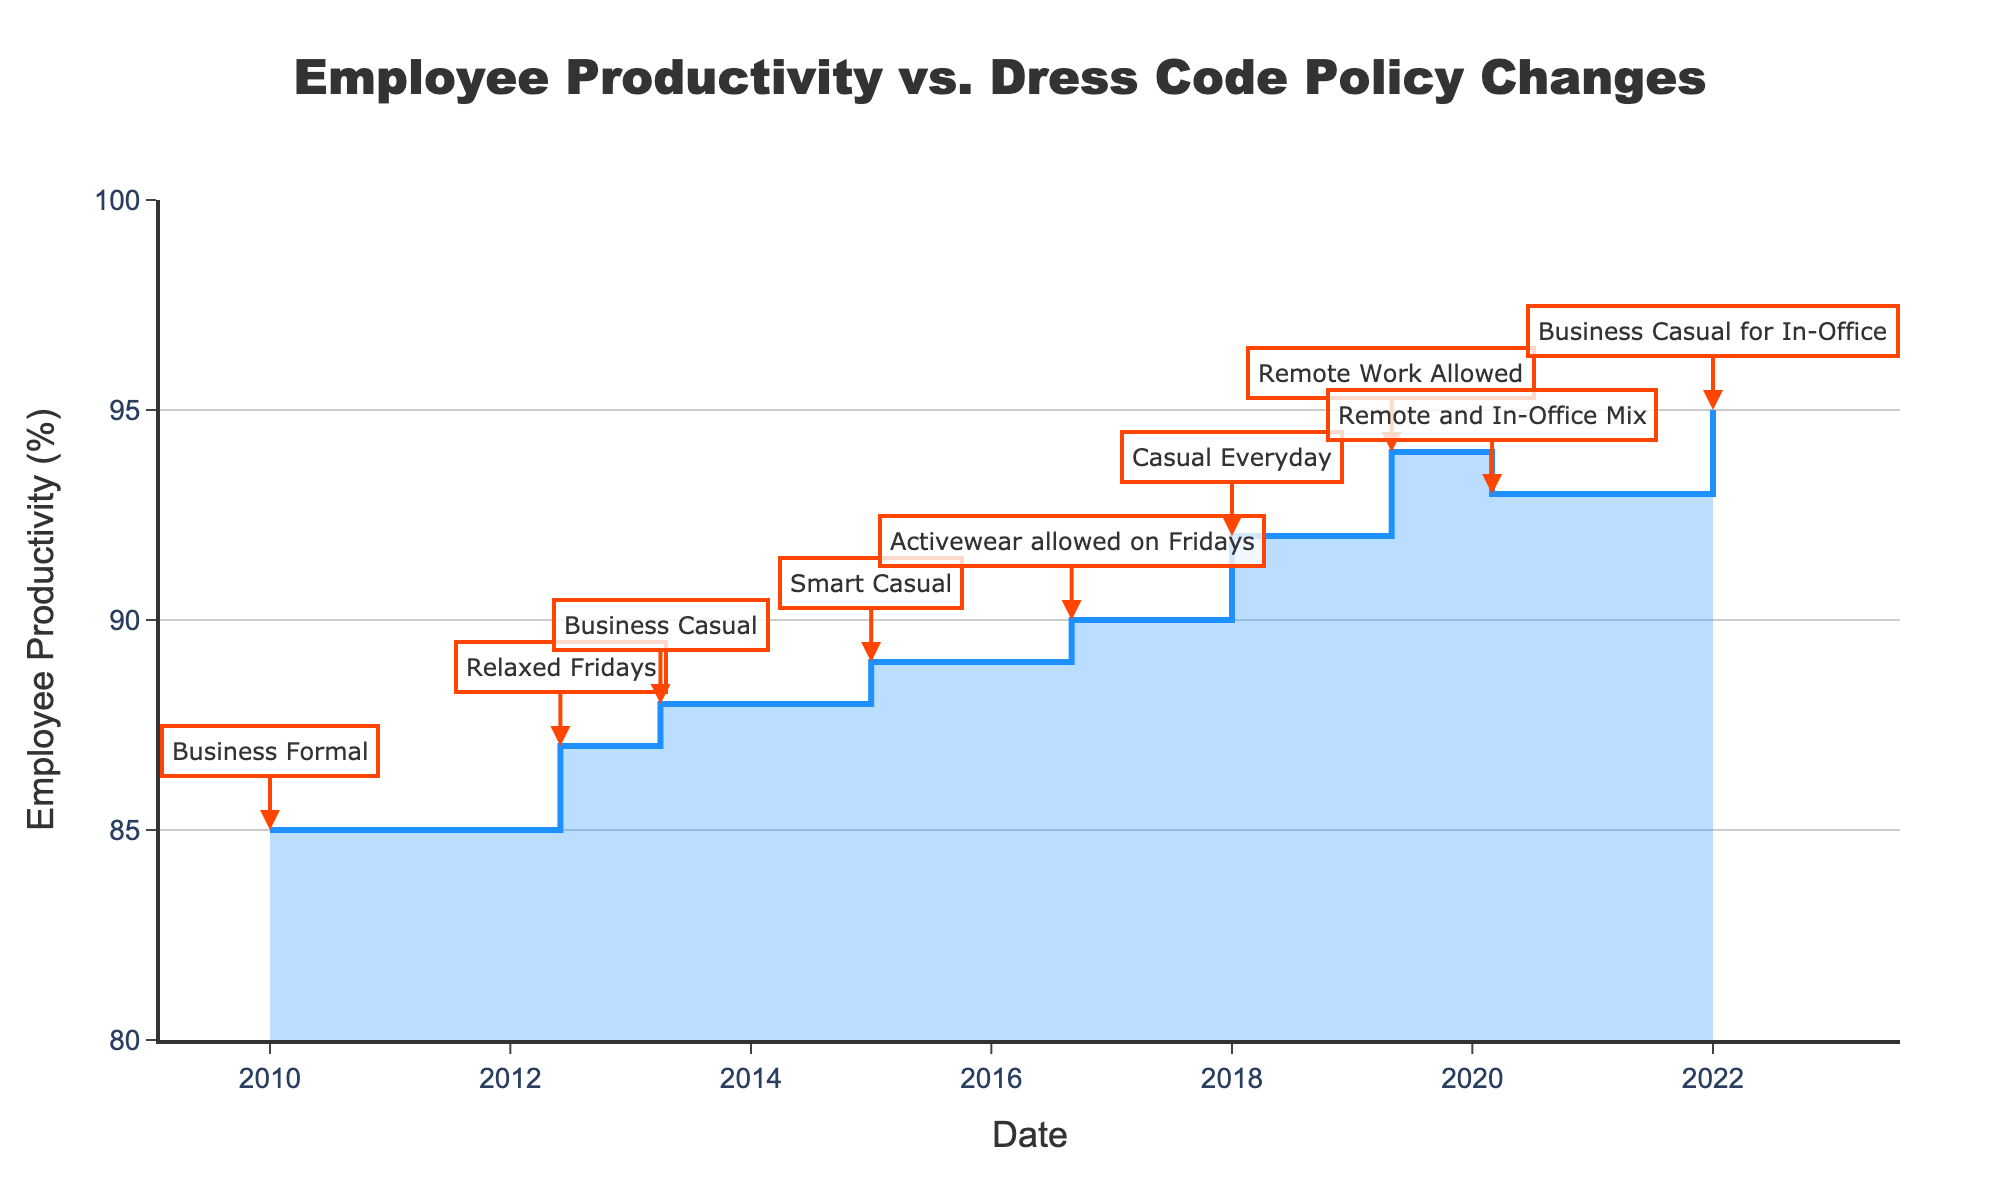What is the title of the chart? The title of the chart is displayed at the top center and reads "Employee Productivity vs. Dress Code Policy Changes".
Answer: Employee Productivity vs. Dress Code Policy Changes Which dress code policy corresponds to the highest employee productivity? By looking at the peak value on the y-axis and identifying the corresponding label, it shows that "Business Casual for In-Office" has the highest productivity at 95%.
Answer: Business Casual for In-Office How many distinct dress code policy changes are annotated on the chart? Counting the annotated labels on the chart reveals 9 distinct dress code policy changes.
Answer: 9 What productivity percentage change is observed from the "Business Formal" policy to "Casual Everyday"? "Business Formal" has a productivity of 85%, and "Casual Everyday" has 92%. The change is calculated as 92% - 85% = 7%.
Answer: 7% Which period saw the largest increase in productivity percentage and by how much? By comparing the step heights, the largest increase is from "Remote Work Allowed" (94%) to "Remote and In-Office Mix" (93%). The increase is 94% - 93% = 1%.
Answer: Remote Work Allowed to Remote and In-Office Mix, 1% What is the productivity percentage in 2013, and what dress code policy was implemented at that time? Looking at the date 2013, the productivity percentage was 88%, and the dress code policy was "Business Casual".
Answer: 88%, Business Casual How does the productivity trend change after each new dress code policy is introduced? Examining the steps, productivity increases consecutively after each dress code policy change, except for the "Remote and In-Office Mix" where there is a slight decrease.
Answer: Increases, except for a slight decrease at "Remote and In-Office Mix" Which years marked the introduction of a "Casual" dress code in the policies? The "Casual Everyday" policy was introduced in 2018, and later, in the year 2022, "Business Casual for In-Office".
Answer: 2018 and 2022 What is the overall trend of employee productivity from 2010 to 2022? The overall trend shows a general increase in employee productivity from 85% in 2010 to 95% in 2022.
Answer: Increasing What was the employee productivity in 2020 and how does it compare to the productivity in 2019? In 2020, the productivity was 93%, while in 2019, it was 94%, showing a decrease of 1%.
Answer: 93%, a decrease of 1% from 2019 